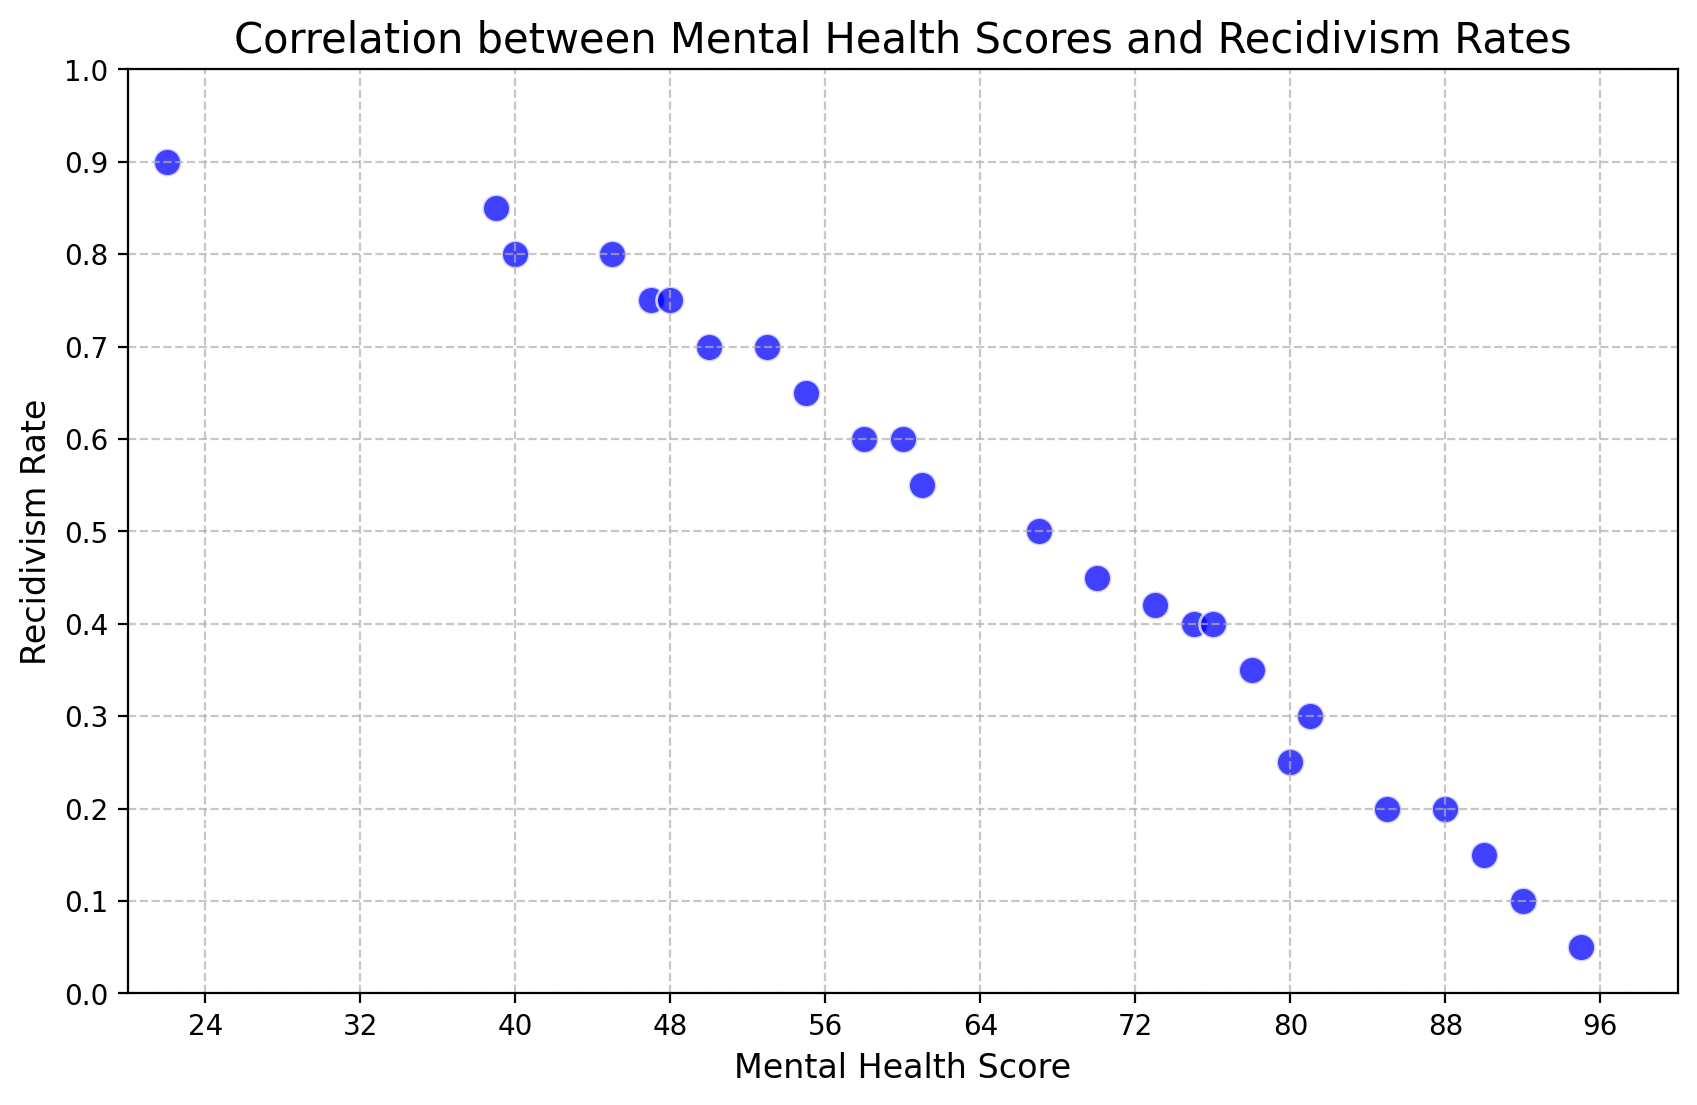What is the general trend between mental health scores and recidivism rates as shown in the plot? To determine the general trend, observe whether the points on the scatter plot form a pattern. The points generally show a downward trend, indicating that as mental health scores increase, recidivism rates tend to decrease.
Answer: As mental health scores increase, recidivism rates decrease Which inmate has the highest mental health score, and what is their recidivism rate? To find the inmate with the highest mental health score, look for the highest x-value on the scatter plot and then locate the corresponding y-value. The highest mental health score is 95, and the recidivism rate for this inmate is approximately 0.05.
Answer: Mental health score of 95, recidivism rate of 0.05 Compare the recidivism rates of inmates with mental health scores of 60 and 85. Which is higher? Locate the points on the scatter plot for mental health scores of 60 and 85 (x-values) and compare their corresponding y-values (recidivism rates). The recidivism rate at 60 is 0.6, while at 85, it is 0.2. Therefore, the recidivism rate is higher for the inmate with a score of 60.
Answer: 0.6 is higher than 0.2 What is the average recidivism rate for inmates with mental health scores below 50? Identify the points with x-values (mental health scores) below 50 and calculate the average of their corresponding y-values (recidivism rates). The scores below 50 are 22 (0.9), 39 (0.85), 40 (0.8), 45 (0.8), and 47 (0.75). The average is (0.9 + 0.85 + 0.8 + 0.8 + 0.75) / 5 = 4.1 / 5 = 0.82.
Answer: 0.82 What is the range of recidivism rates for inmates with mental health scores between 70 and 90? Locate the points within the mental health score range of 70 to 90 and determine the minimum and maximum recidivism rates among these points. The scores are 70 (0.45), 73 (0.42), 75 (0.4), 76 (0.4), 78 (0.35), 80 (0.25), 81 (0.3), 85 (0.2), 88 (0.2), and 90 (0.15). The minimum is 0.15, and the maximum is 0.45.
Answer: 0.15 to 0.45 